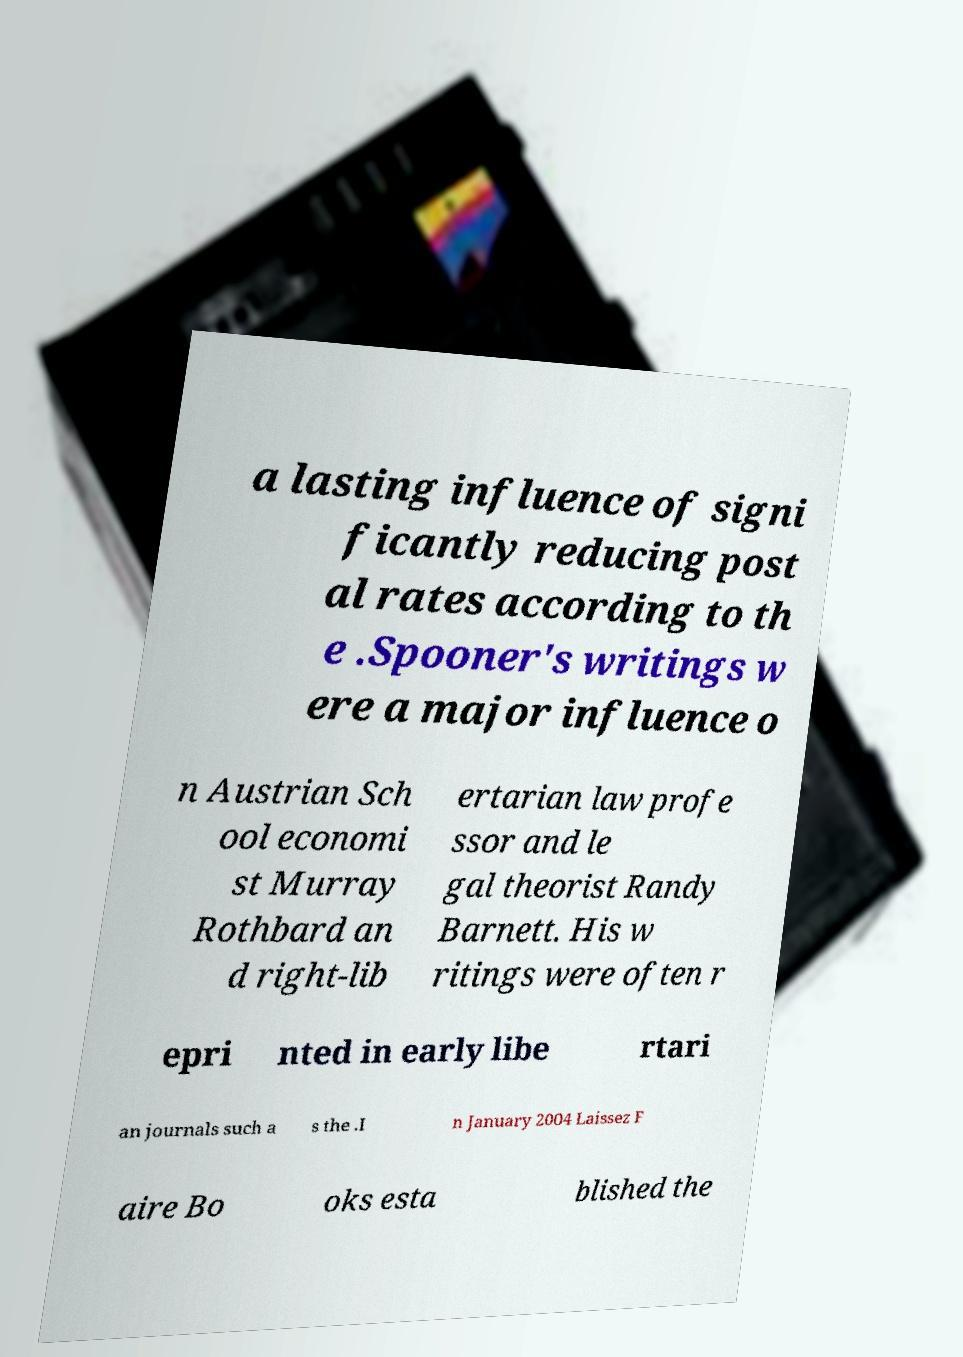There's text embedded in this image that I need extracted. Can you transcribe it verbatim? a lasting influence of signi ficantly reducing post al rates according to th e .Spooner's writings w ere a major influence o n Austrian Sch ool economi st Murray Rothbard an d right-lib ertarian law profe ssor and le gal theorist Randy Barnett. His w ritings were often r epri nted in early libe rtari an journals such a s the .I n January 2004 Laissez F aire Bo oks esta blished the 